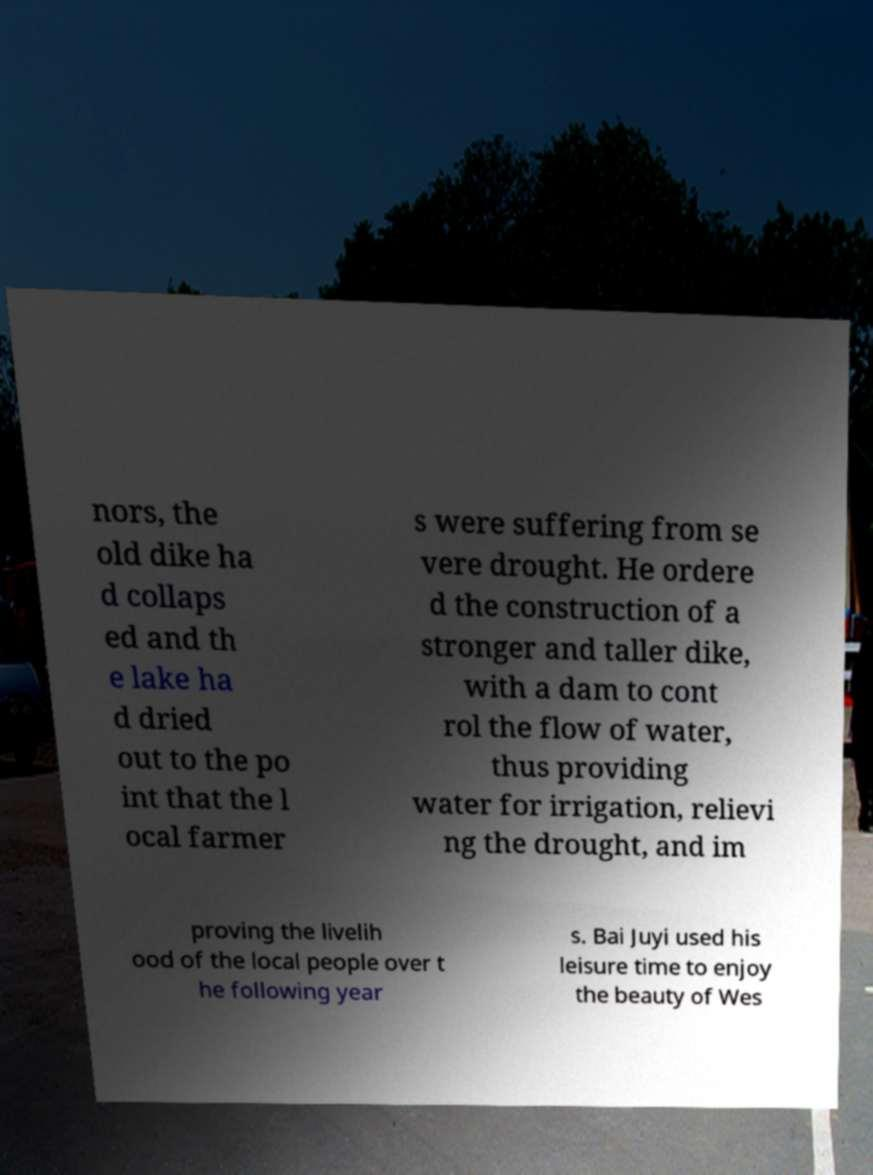Please read and relay the text visible in this image. What does it say? nors, the old dike ha d collaps ed and th e lake ha d dried out to the po int that the l ocal farmer s were suffering from se vere drought. He ordere d the construction of a stronger and taller dike, with a dam to cont rol the flow of water, thus providing water for irrigation, relievi ng the drought, and im proving the livelih ood of the local people over t he following year s. Bai Juyi used his leisure time to enjoy the beauty of Wes 